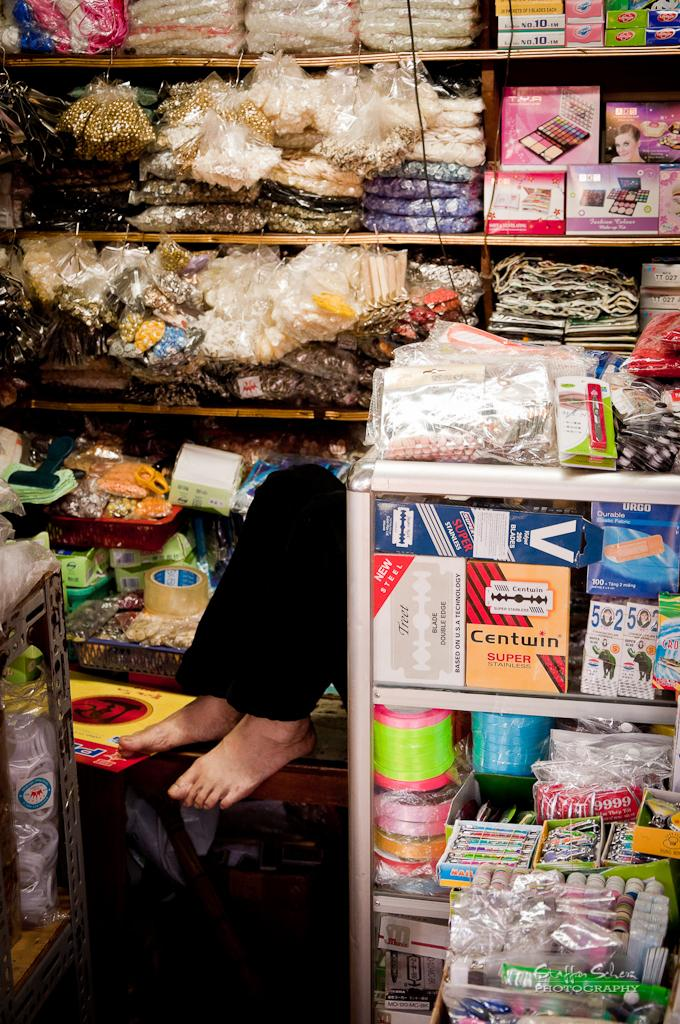<image>
Give a short and clear explanation of the subsequent image. Among the items in a cart is a package of Centwin Super Stainless. 